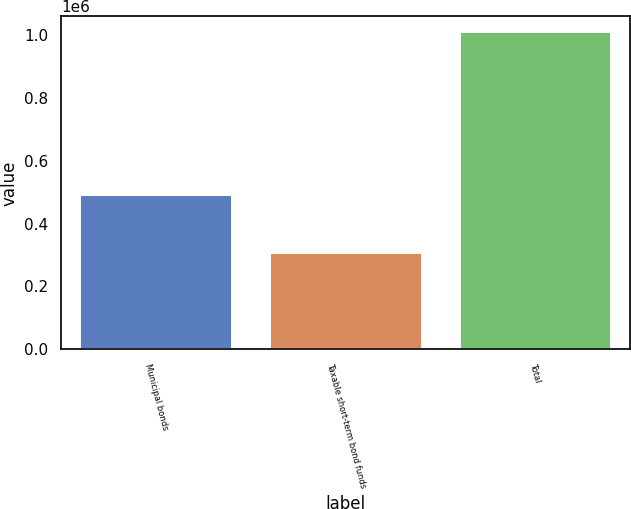Convert chart to OTSL. <chart><loc_0><loc_0><loc_500><loc_500><bar_chart><fcel>Municipal bonds<fcel>Taxable short-term bond funds<fcel>Total<nl><fcel>492245<fcel>305574<fcel>1.00966e+06<nl></chart> 